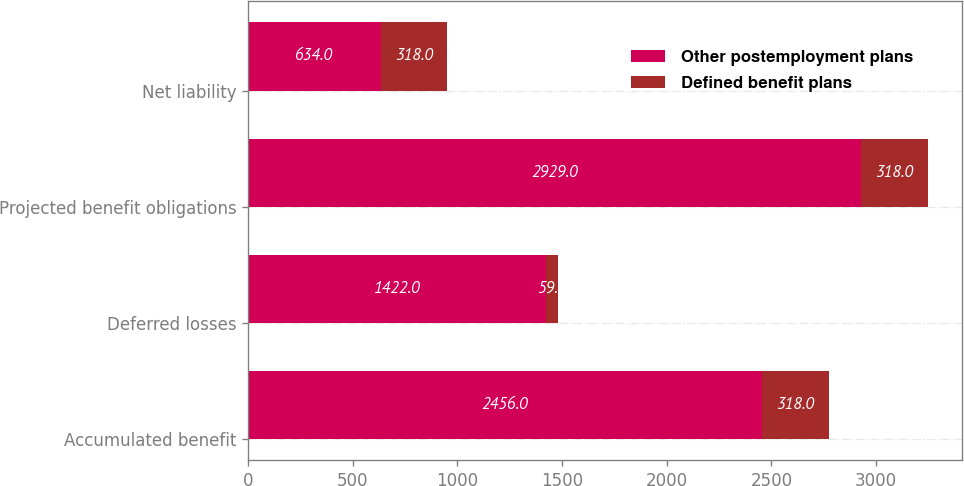Convert chart. <chart><loc_0><loc_0><loc_500><loc_500><stacked_bar_chart><ecel><fcel>Accumulated benefit<fcel>Deferred losses<fcel>Projected benefit obligations<fcel>Net liability<nl><fcel>Other postemployment plans<fcel>2456<fcel>1422<fcel>2929<fcel>634<nl><fcel>Defined benefit plans<fcel>318<fcel>59<fcel>318<fcel>318<nl></chart> 